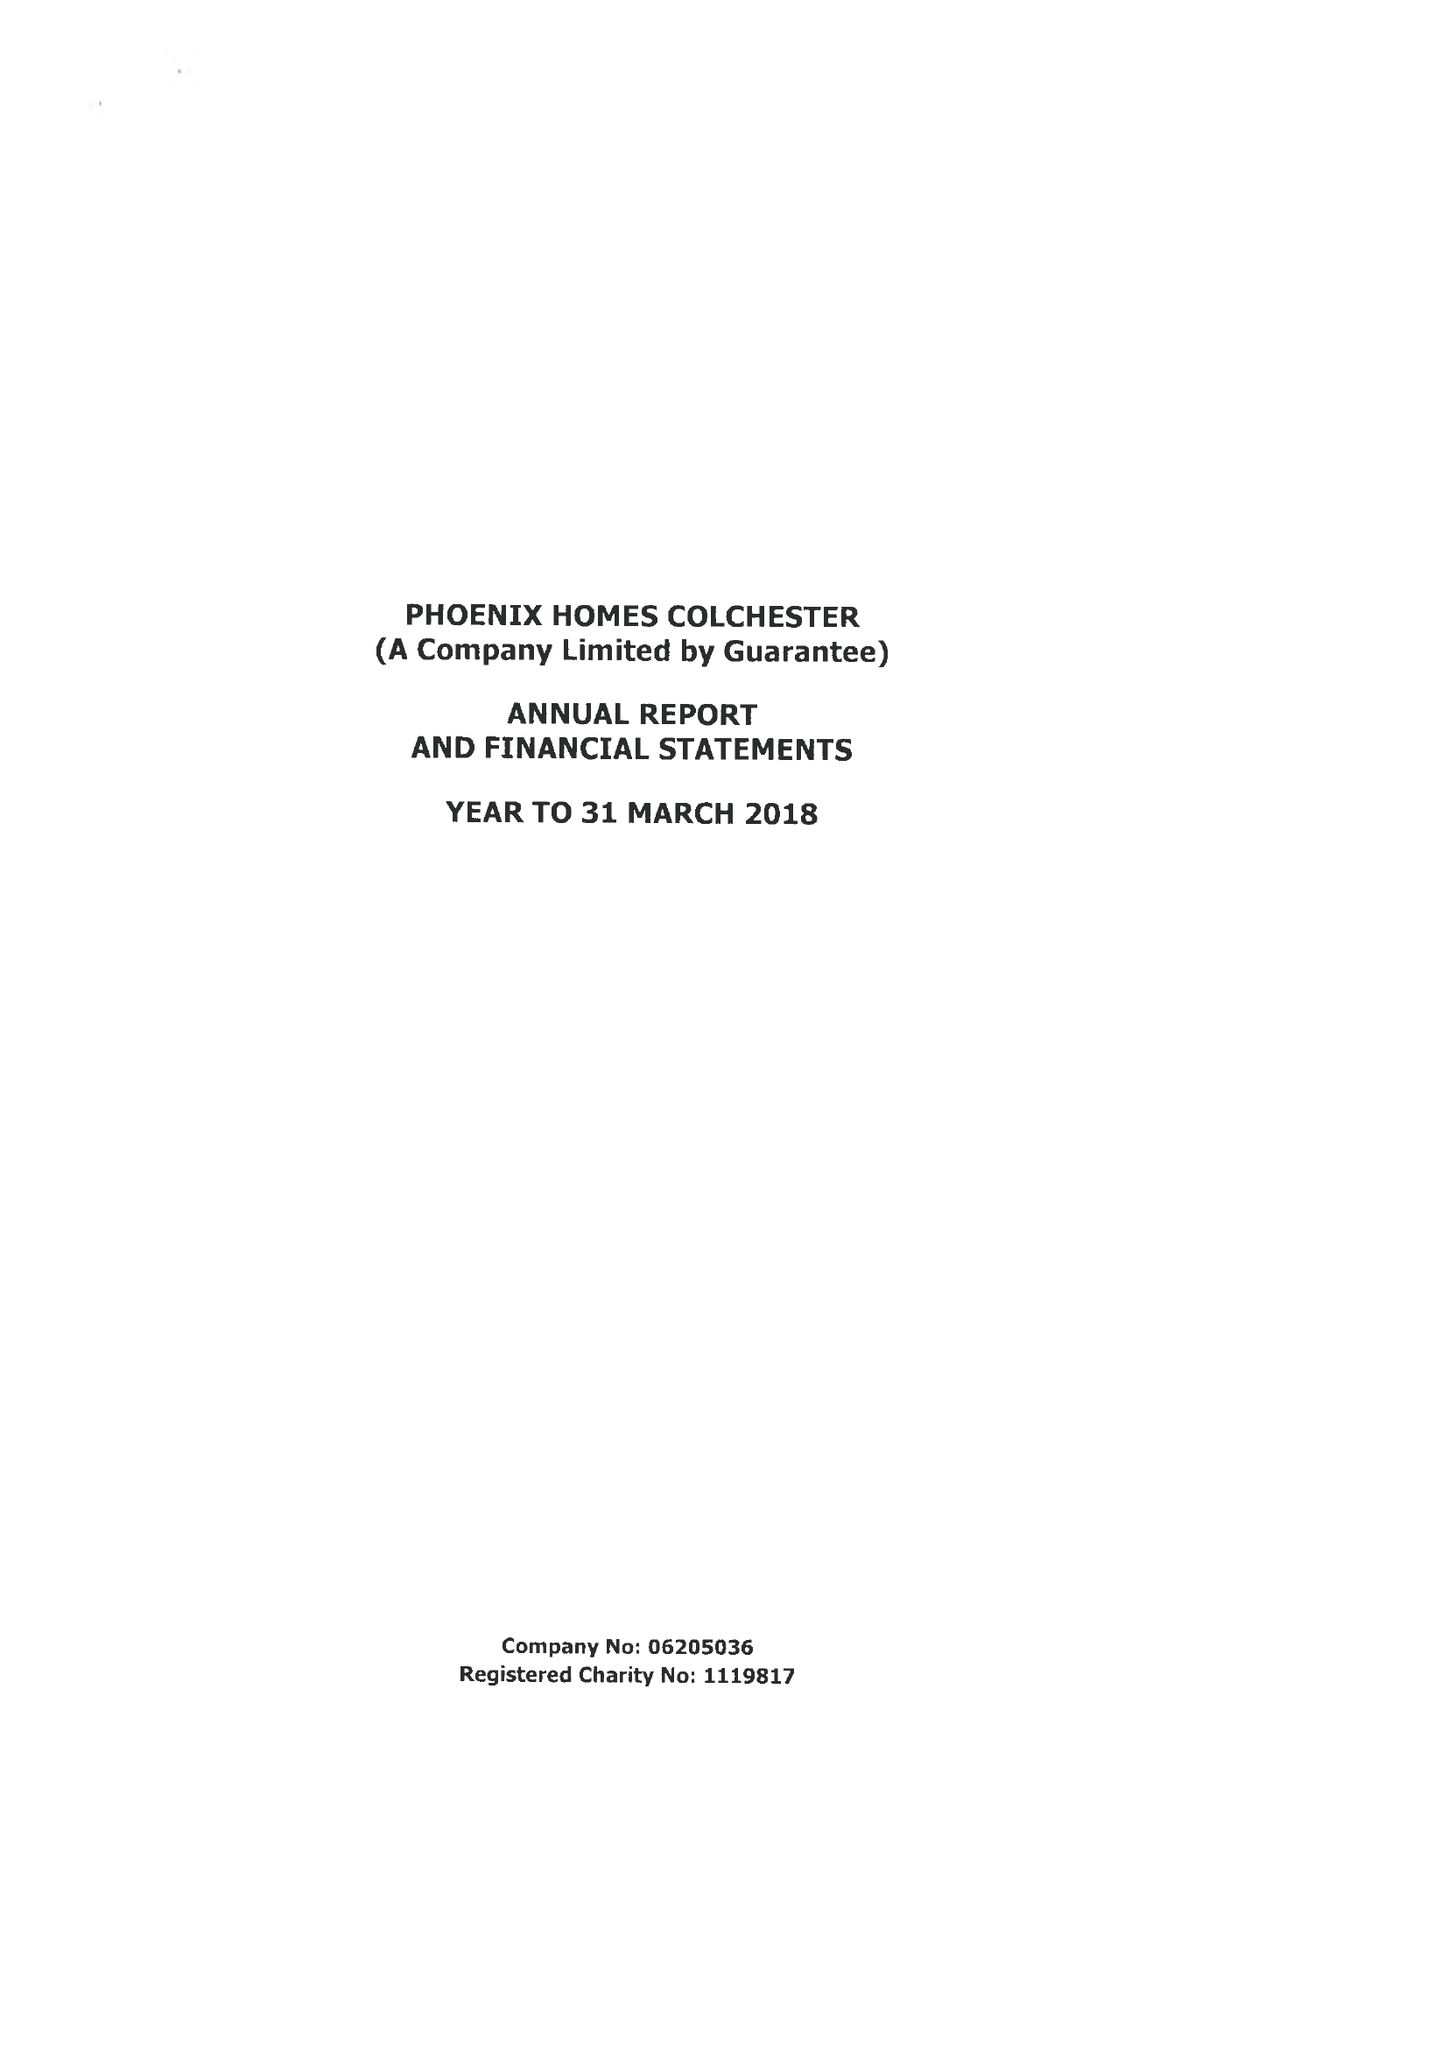What is the value for the report_date?
Answer the question using a single word or phrase. 2018-03-31 